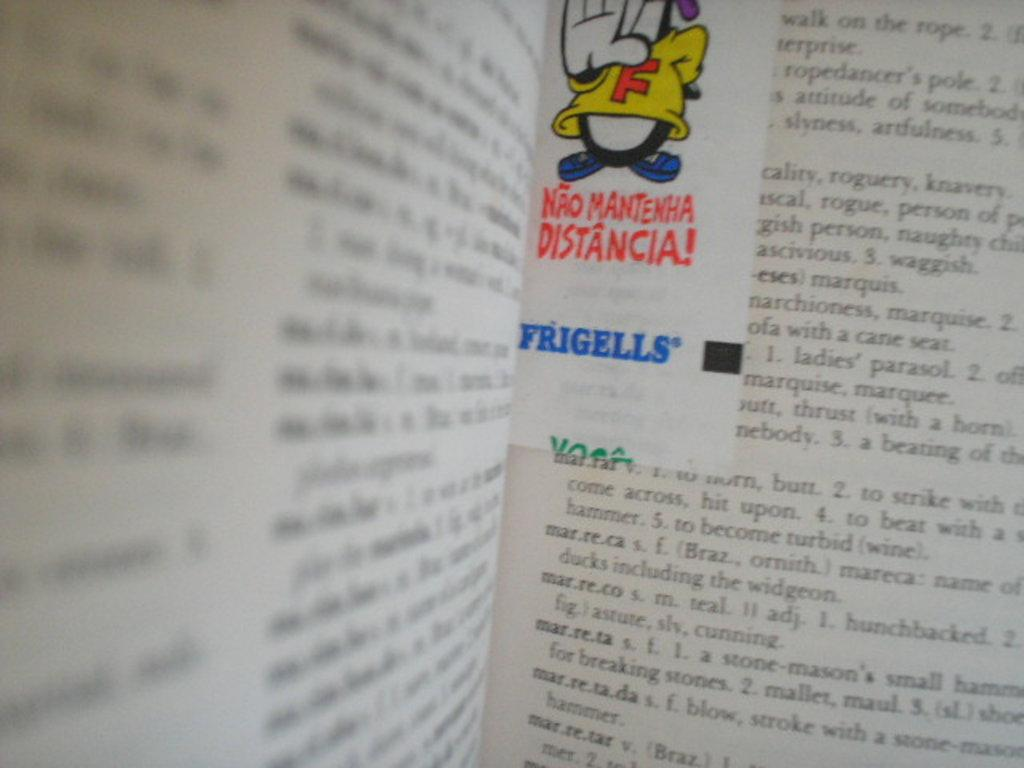<image>
Write a terse but informative summary of the picture. An open dictionary showing the words marreca, marreco, etc. 